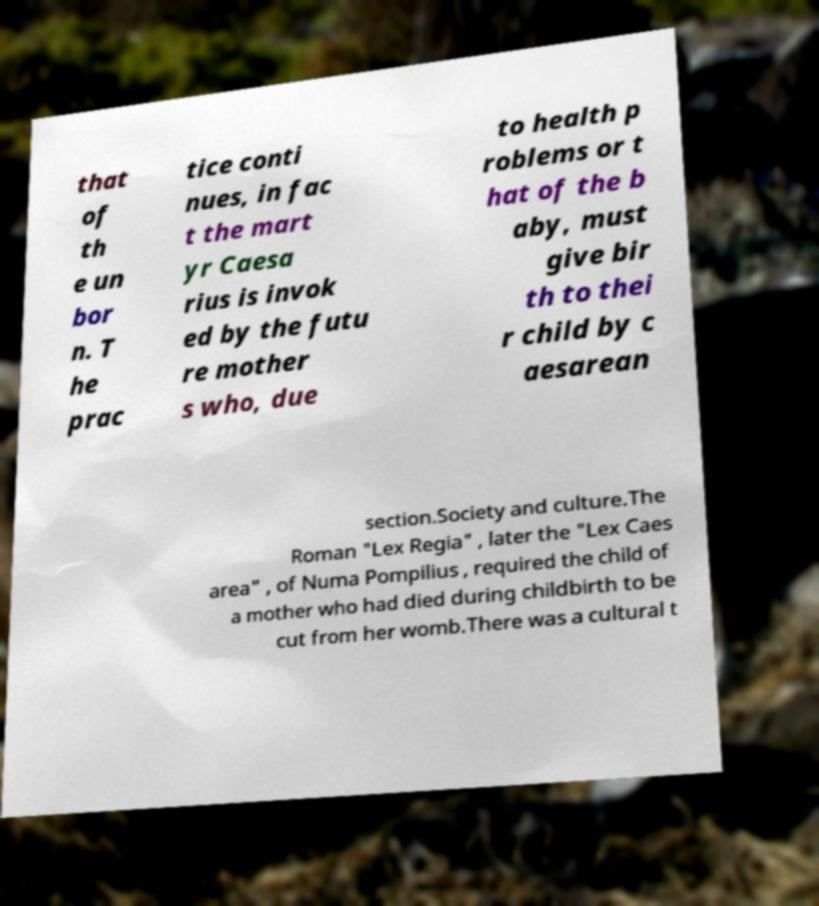Could you assist in decoding the text presented in this image and type it out clearly? that of th e un bor n. T he prac tice conti nues, in fac t the mart yr Caesa rius is invok ed by the futu re mother s who, due to health p roblems or t hat of the b aby, must give bir th to thei r child by c aesarean section.Society and culture.The Roman "Lex Regia" , later the "Lex Caes area" , of Numa Pompilius , required the child of a mother who had died during childbirth to be cut from her womb.There was a cultural t 